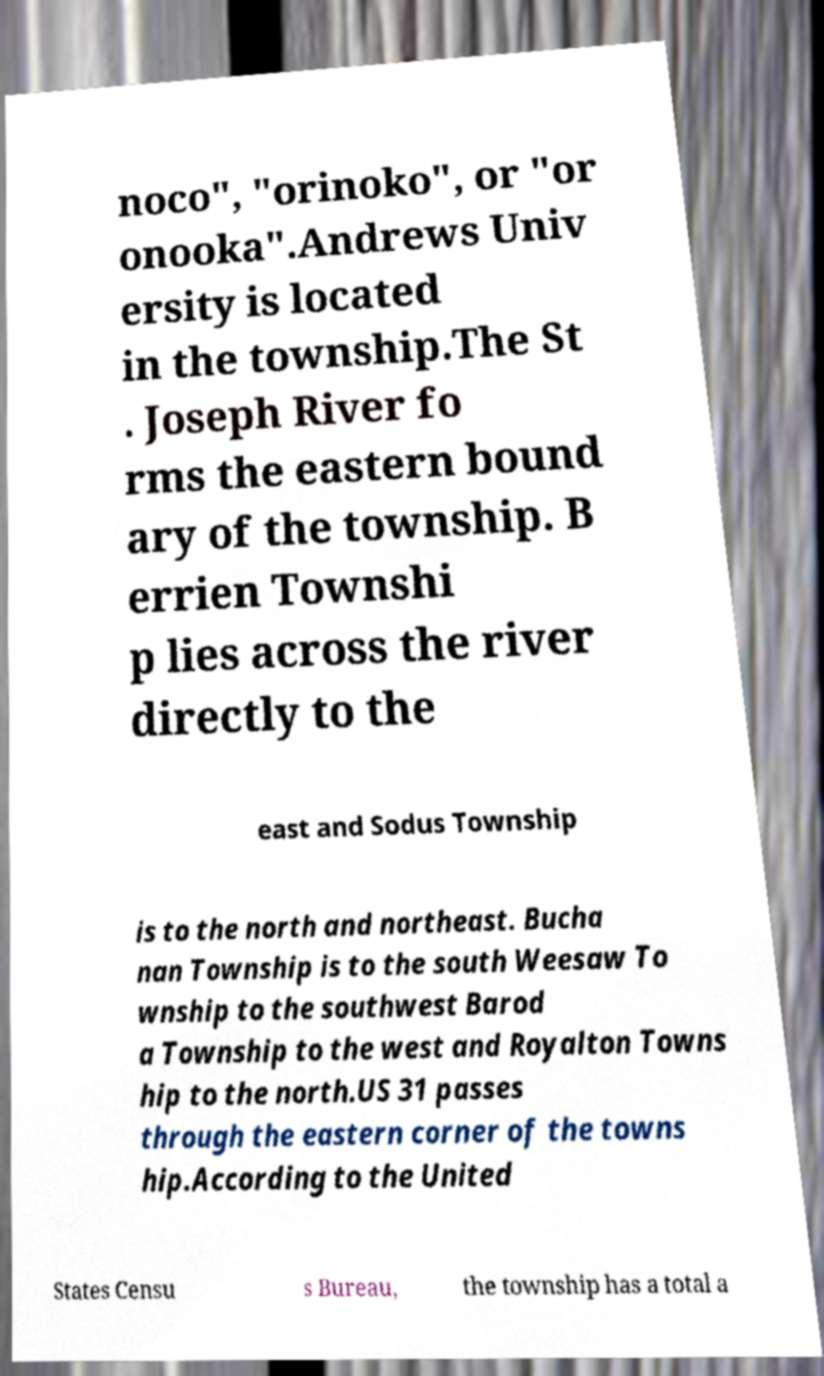Please read and relay the text visible in this image. What does it say? noco", "orinoko", or "or onooka".Andrews Univ ersity is located in the township.The St . Joseph River fo rms the eastern bound ary of the township. B errien Townshi p lies across the river directly to the east and Sodus Township is to the north and northeast. Bucha nan Township is to the south Weesaw To wnship to the southwest Barod a Township to the west and Royalton Towns hip to the north.US 31 passes through the eastern corner of the towns hip.According to the United States Censu s Bureau, the township has a total a 